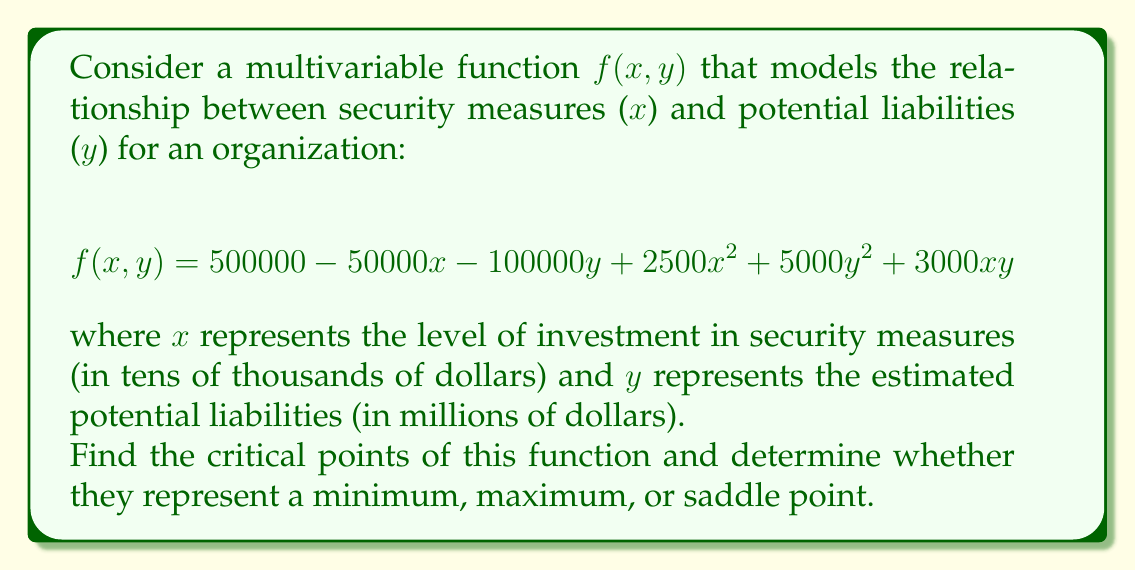Help me with this question. To find the critical points of the function $f(x, y)$, we need to follow these steps:

1. Calculate the partial derivatives of $f$ with respect to $x$ and $y$:

$$\frac{\partial f}{\partial x} = -50000 + 5000x + 3000y$$
$$\frac{\partial f}{\partial y} = -100000 + 10000y + 3000x$$

2. Set both partial derivatives equal to zero and solve the resulting system of equations:

$$\begin{cases}
-50000 + 5000x + 3000y = 0 \\
-100000 + 10000y + 3000x = 0
\end{cases}$$

3. Solve this system:
   Multiply the first equation by 2:
   $$-100000 + 10000x + 6000y = 0$$
   Subtract this from the second equation:
   $$4000y - 3000x = 0$$
   $$y = \frac{3x}{4}$$

   Substitute this back into the first equation:
   $$-50000 + 5000x + 3000(\frac{3x}{4}) = 0$$
   $$-50000 + 5000x + 2250x = 0$$
   $$7250x = 50000$$
   $$x = \frac{50000}{7250} \approx 6.90$$

   Calculate y:
   $$y = \frac{3(6.90)}{4} \approx 5.17$$

4. The critical point is approximately (6.90, 5.17).

5. To determine the nature of this critical point, we need to calculate the second partial derivatives:

   $$\frac{\partial^2 f}{\partial x^2} = 5000$$
   $$\frac{\partial^2 f}{\partial y^2} = 10000$$
   $$\frac{\partial^2 f}{\partial x\partial y} = \frac{\partial^2 f}{\partial y\partial x} = 3000$$

6. Calculate the determinant of the Hessian matrix:

   $$H = \begin{vmatrix} 
   5000 & 3000 \\
   3000 & 10000
   \end{vmatrix} = 50000000 - 9000000 = 41000000 > 0$$

   Since the determinant is positive and $\frac{\partial^2 f}{\partial x^2} > 0$, this critical point is a minimum.
Answer: The critical point of the function is approximately (6.90, 5.17), and it represents a minimum point. 